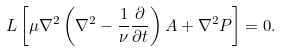<formula> <loc_0><loc_0><loc_500><loc_500>L \left [ \mu \nabla ^ { 2 } \left ( \nabla ^ { 2 } - \frac { 1 } { \nu } \frac { \partial } { \partial t } \right ) A + \nabla ^ { 2 } P \right ] = 0 .</formula> 